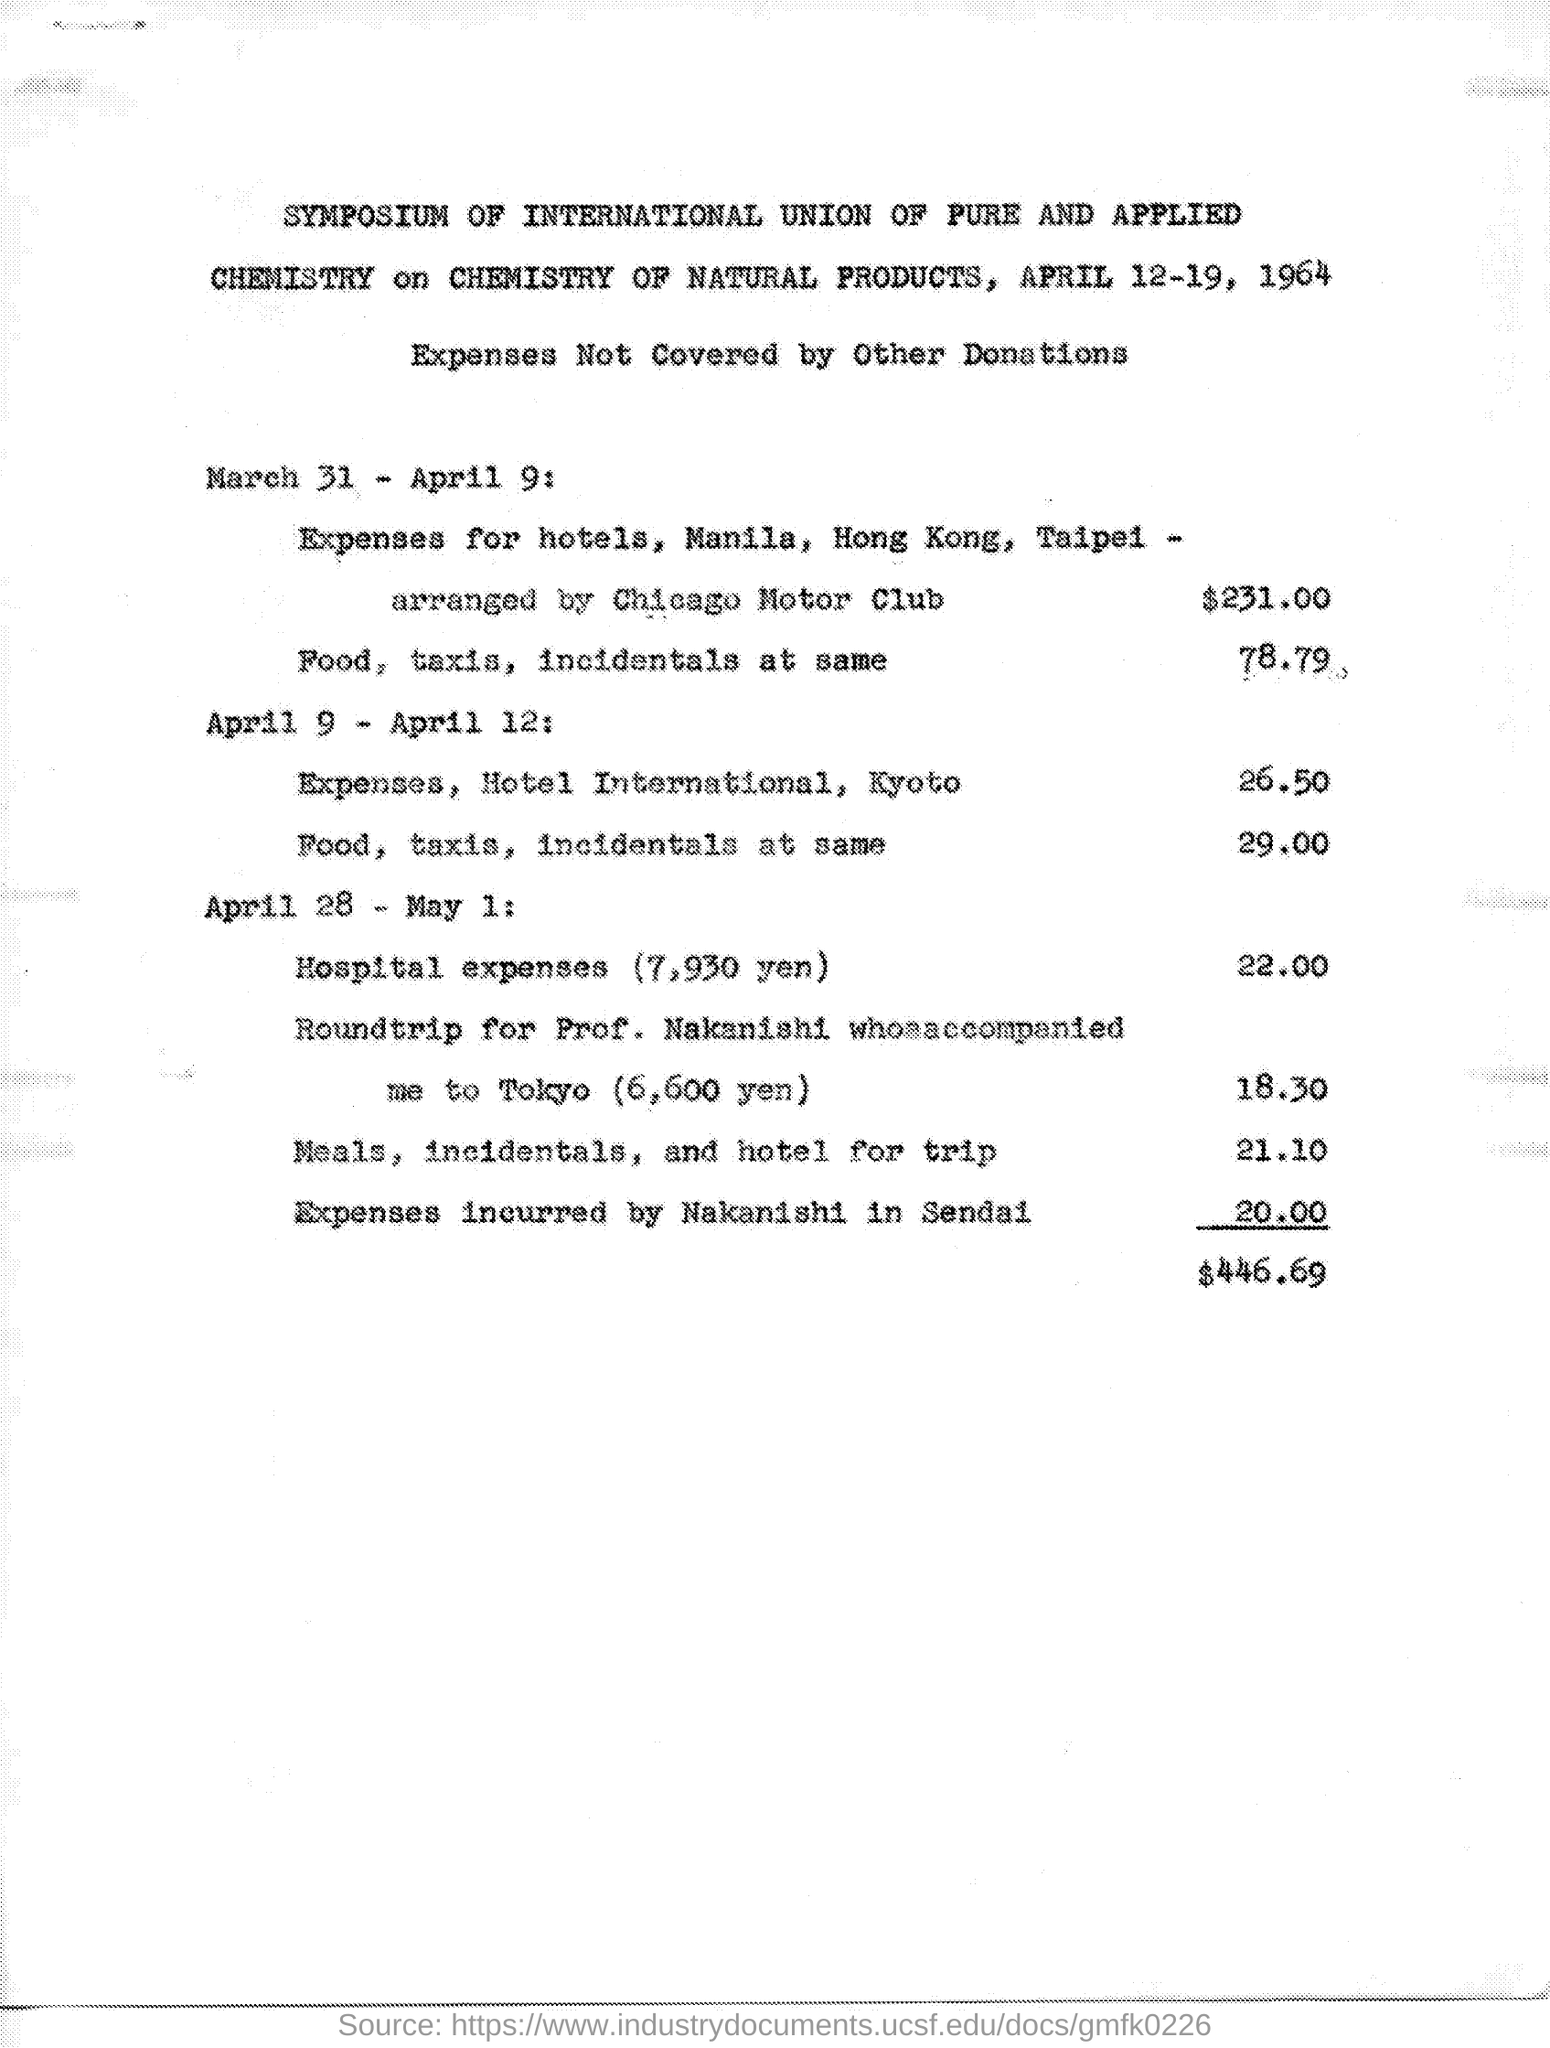When is the symposium going to be held?
Offer a very short reply. APRIL 12-19, 1964. What is the amount for food, taxis, incidentals at same from March 31- April 9?
Offer a terse response. 78.79. What is the total amount at the end?
Make the answer very short. $446.69. 